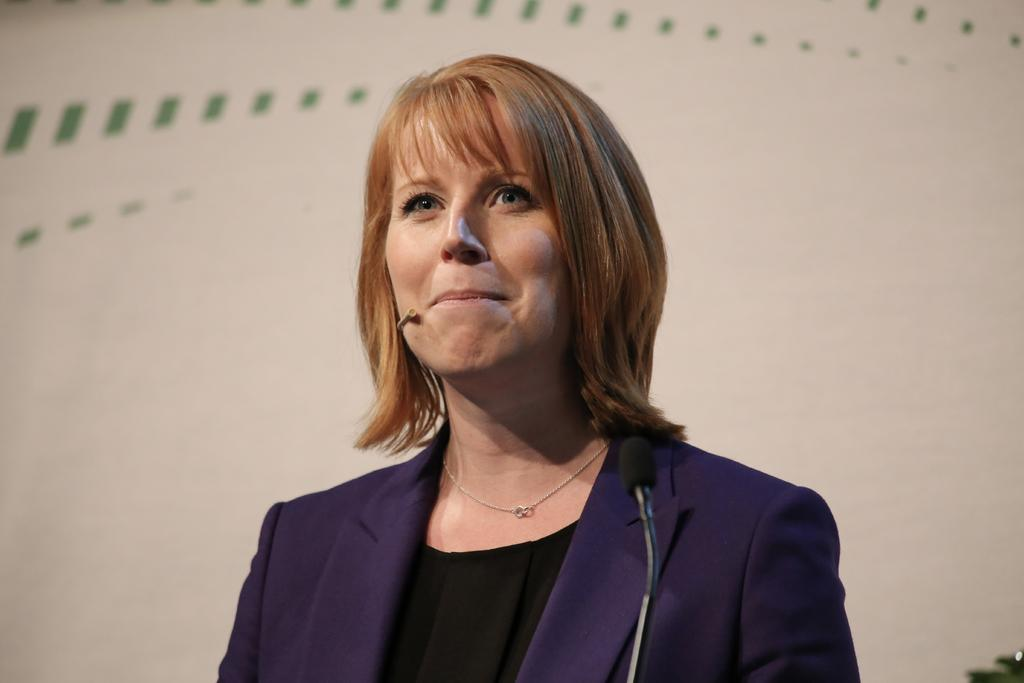Who is the main subject in the image? There is a woman in the image. What is the woman wearing? The woman is wearing a black dress and a purple blazer. What object is in front of the woman? There is a microphone in front of the woman. Can you describe the background of the image? The background of the image is cream and green colored. What type of tank can be seen in the background of the image? There is no tank present in the background of the image. How does the secretary assist the woman in the image? There is no secretary present in the image. 